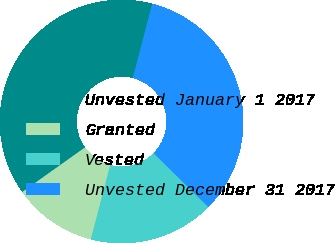<chart> <loc_0><loc_0><loc_500><loc_500><pie_chart><fcel>Unvested January 1 2017<fcel>Granted<fcel>Vested<fcel>Unvested December 31 2017<nl><fcel>38.89%<fcel>11.11%<fcel>16.67%<fcel>33.33%<nl></chart> 